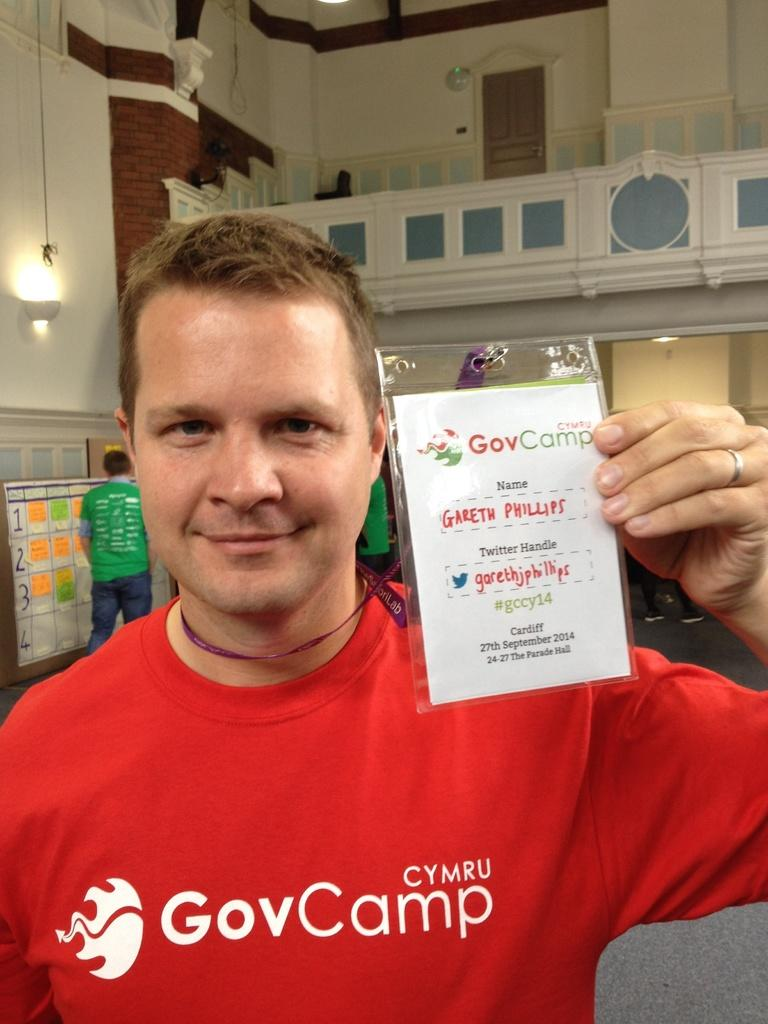Who is present in the image? There is a man in the image. What is the man holding? The man is holding a card. Where is the card located in relation to the man? The card is in the man's hand. What can be seen on the floor in the image? The image shows a floor. What is visible in the background of the image? There are lights, a door, a wall, a board, and a person in the background of the image. What type of creature is sitting on the lamp in the image? There is no lamp present in the image, and therefore no creature can be observed sitting on it. 